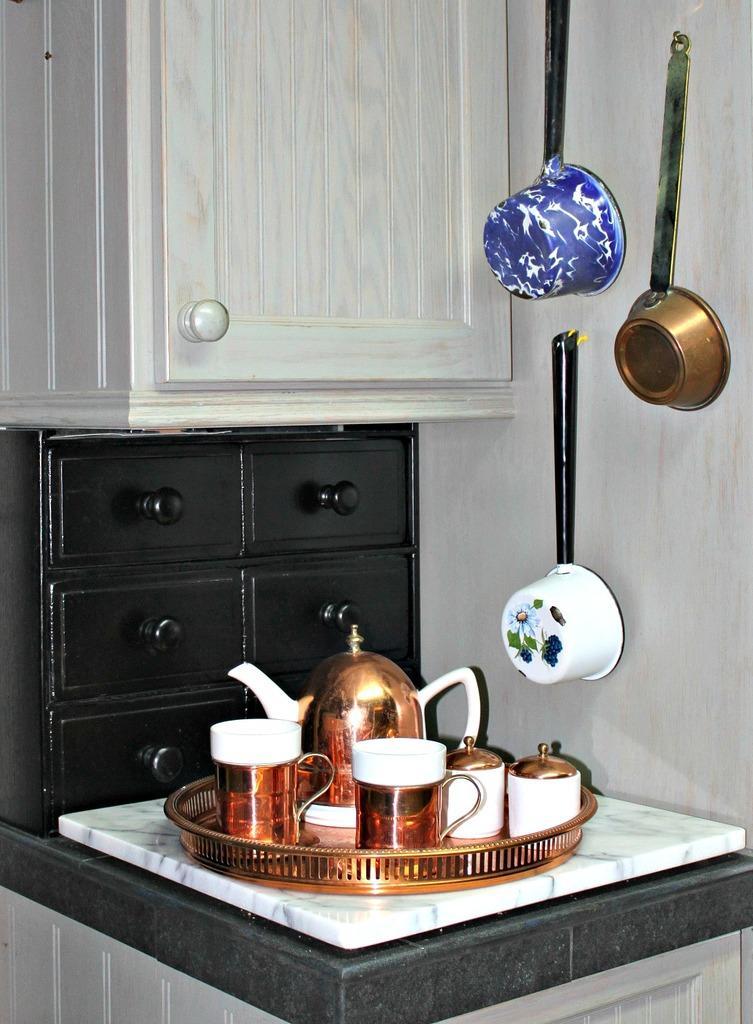In one or two sentences, can you explain what this image depicts? In the center of the image there are cups and mug on the platform. In the background of the image there are cupboards. There are utensils on the wall. 